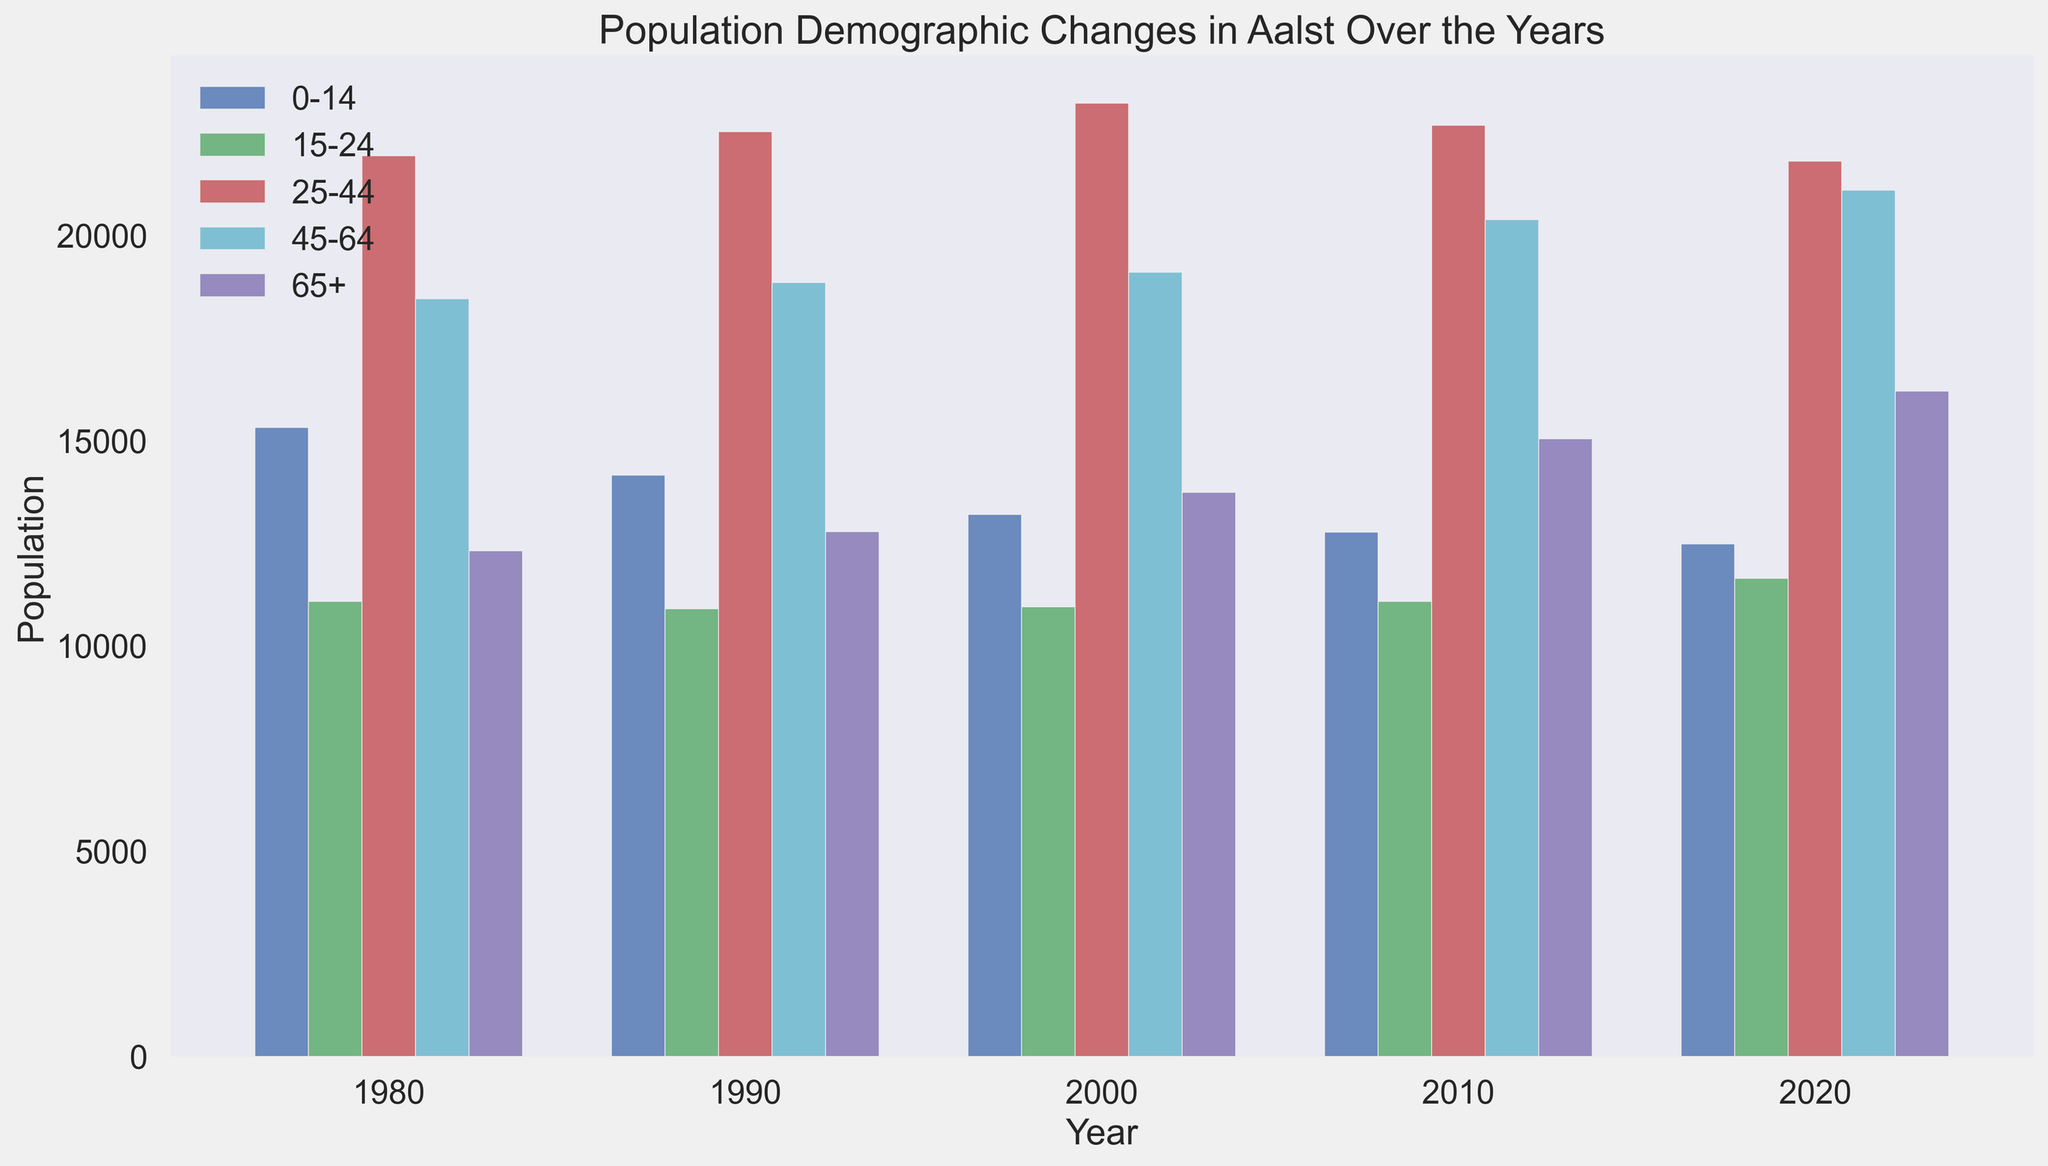What is the overall trend in the population of the 0-14 age group from 1980 to 2020? From the chart, observe the heights of the blue bars representing the 0-14 age group from 1980 to 2020. The population decreases steadily over the years.
Answer: Decreasing How does the population of the 25-44 age group in 2020 compare to its population in 1980? Compare the heights of the red bars representing the 25-44 age group in 1980 and 2020. The bar in 1980 is slightly taller than the bar in 2020, indicating a higher population in 1980.
Answer: Decreased Which age group had the largest increase in population between 1980 and 2020? Compare the height differences of bars in each age group from 1980 to 2020. The 65+ age group, represented by purple bars, shows the largest increase.
Answer: 65+ In which decade did the 45-64 age group experience the most significant population growth? Compare the height changes of the cyan bars representing the 45-64 age group over the decades. The most significant growth occurs between 2000 and 2010.
Answer: 2000-2010 What is the average population size of the 15-24 age group over the four decades? Sum the populations of the 15-24 age group for each decade and divide by the number of decades ((11075 + 10900 + 10950 + 11075 + 11640) / 5).
Answer: 11128 Which age group consistently had the smallest population from 1980 to 2020? Identify the age group with the consistently shortest bars across all decades. The 65+ age group shows this trend until the last few decades where it changes, but overall, 15-24 is the smallest.
Answer: 15-24 By what percentage did the population of the 65+ age group increase from 1980 to 2020? Calculate the percentage increase from 1980 to 2020 using the values ((16200 - 12305) / 12305) * 100%.
Answer: Approximately 31.7% In which year did the 25-44 age group peak? Compare the heights of the red bars to find the tallest one, indicating the peak population. The tallest red bar appears in the year 2000.
Answer: 2000 How does the population of the 45-64 age group in 2010 compare to the 0-14 age group in the same year? Compare the heights of the cyan and blue bars in 2010. The cyan bar (45-64 age group) is taller than the blue bar (0-14 age group).
Answer: Higher What is the sum of the populations of all age groups in the year 2000? Add up the populations of all age groups in the year 2000: 13200 + 10950 + 23210 + 19090 + 13730.
Answer: 80180 